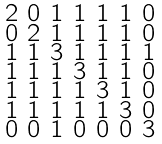<formula> <loc_0><loc_0><loc_500><loc_500>\begin{smallmatrix} 2 & 0 & 1 & 1 & 1 & 1 & 0 \\ 0 & 2 & 1 & 1 & 1 & 1 & 0 \\ 1 & 1 & 3 & 1 & 1 & 1 & 1 \\ 1 & 1 & 1 & 3 & 1 & 1 & 0 \\ 1 & 1 & 1 & 1 & 3 & 1 & 0 \\ 1 & 1 & 1 & 1 & 1 & 3 & 0 \\ 0 & 0 & 1 & 0 & 0 & 0 & 3 \end{smallmatrix}</formula> 